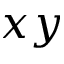<formula> <loc_0><loc_0><loc_500><loc_500>x y</formula> 